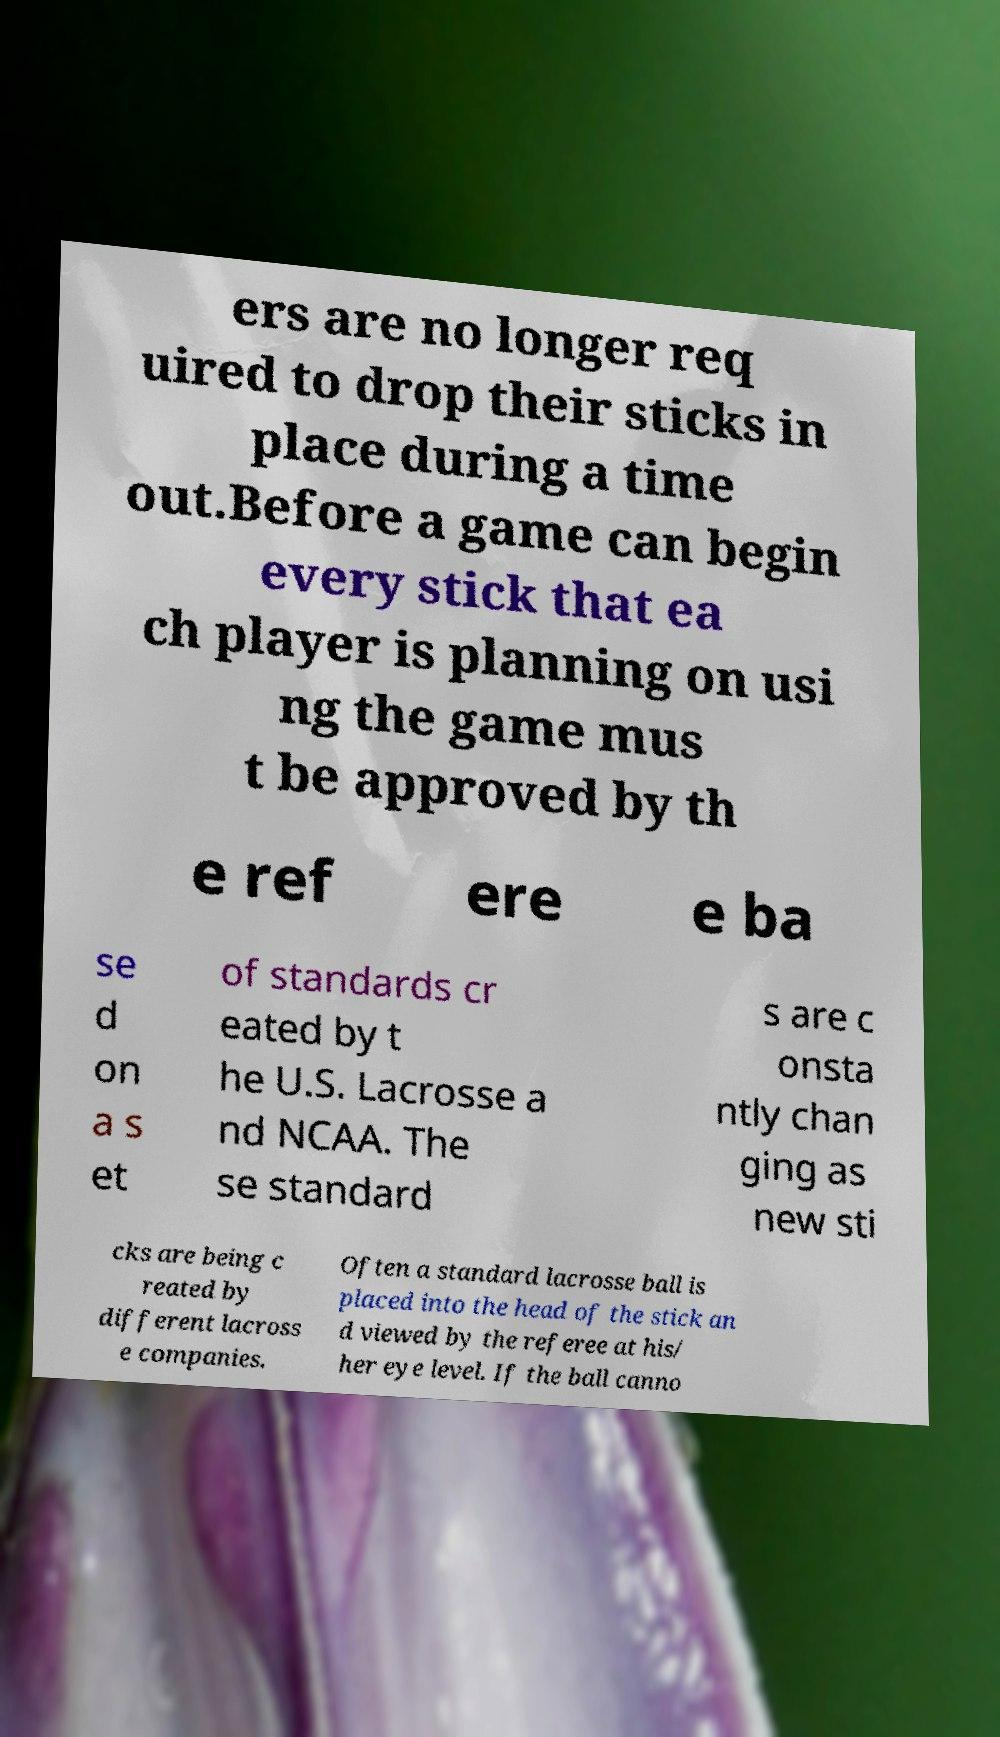Please identify and transcribe the text found in this image. ers are no longer req uired to drop their sticks in place during a time out.Before a game can begin every stick that ea ch player is planning on usi ng the game mus t be approved by th e ref ere e ba se d on a s et of standards cr eated by t he U.S. Lacrosse a nd NCAA. The se standard s are c onsta ntly chan ging as new sti cks are being c reated by different lacross e companies. Often a standard lacrosse ball is placed into the head of the stick an d viewed by the referee at his/ her eye level. If the ball canno 